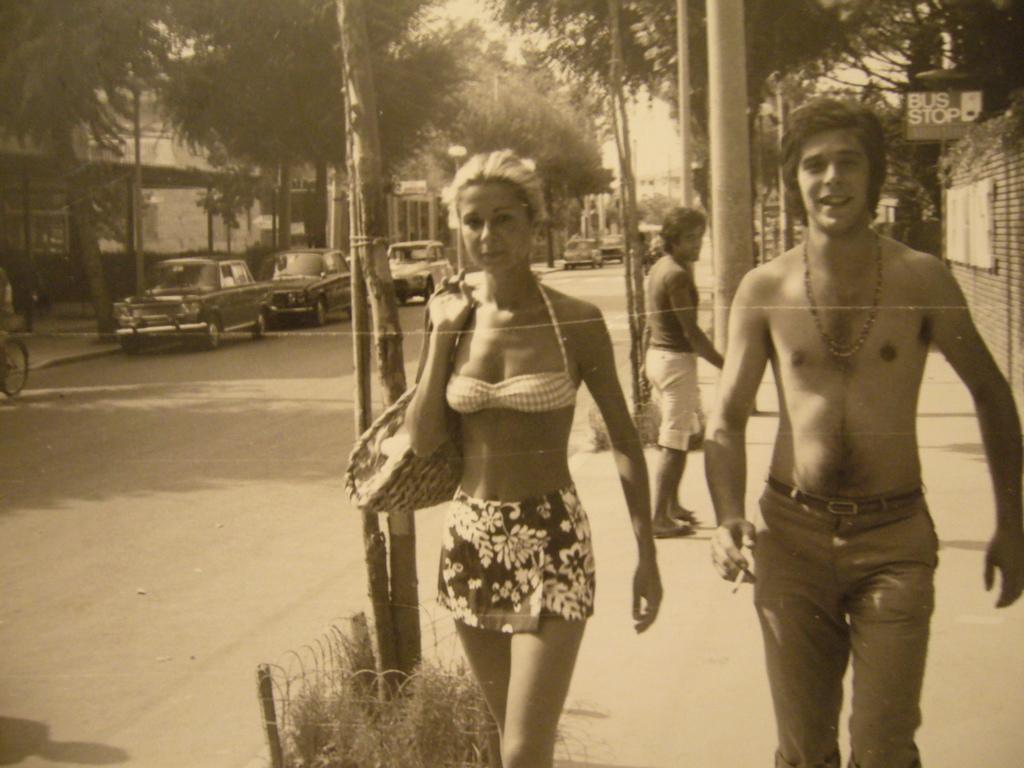How would you summarize this image in a sentence or two? In the picture I can see a man and a woman walking on the side of the road. I can see a man on the right side is holding a cigarette in his right hand and there is a smile on his face. I can see a woman on the left side is holding a bag. There is another man on the side of the road. I can see the cars on the road. I can see the buildings and trees. There is a bicycle on the left side. 